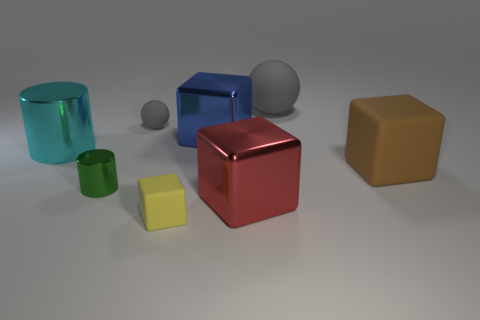Do the tiny matte thing behind the green metal object and the large sphere have the same color?
Make the answer very short. Yes. What is the material of the big thing that is the same color as the small matte sphere?
Make the answer very short. Rubber. There is a ball in front of the big gray sphere; is its color the same as the big rubber object behind the large blue metallic cube?
Ensure brevity in your answer.  Yes. There is another large shiny thing that is the same shape as the blue shiny thing; what is its color?
Your answer should be compact. Red. Is the shape of the tiny matte object that is in front of the cyan metal cylinder the same as the large thing in front of the brown matte block?
Keep it short and to the point. Yes. Is the size of the green cylinder the same as the gray object behind the tiny gray sphere?
Your answer should be very brief. No. Are there more objects than tiny cyan metal balls?
Keep it short and to the point. Yes. Do the gray ball that is right of the yellow object and the big thing to the left of the tiny yellow matte cube have the same material?
Keep it short and to the point. No. What is the brown thing made of?
Your answer should be compact. Rubber. Is the number of blue blocks that are left of the small matte block greater than the number of small green metallic cylinders?
Offer a terse response. No. 